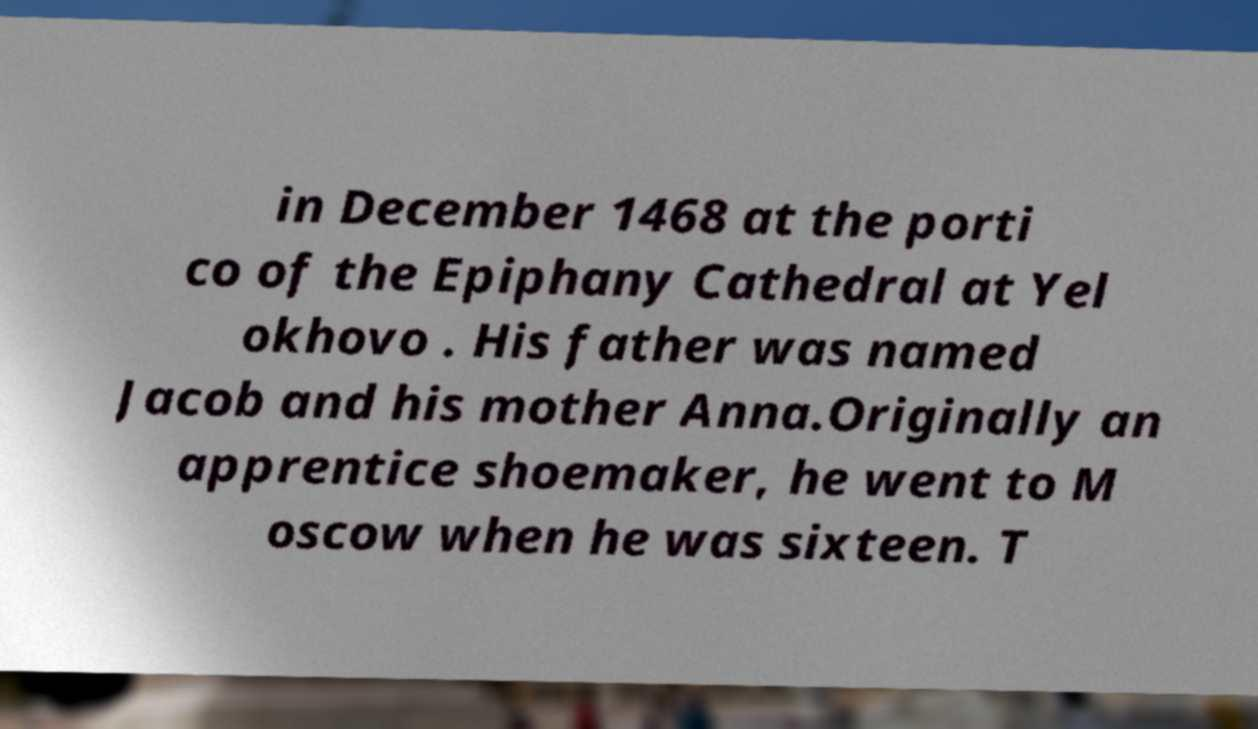For documentation purposes, I need the text within this image transcribed. Could you provide that? in December 1468 at the porti co of the Epiphany Cathedral at Yel okhovo . His father was named Jacob and his mother Anna.Originally an apprentice shoemaker, he went to M oscow when he was sixteen. T 